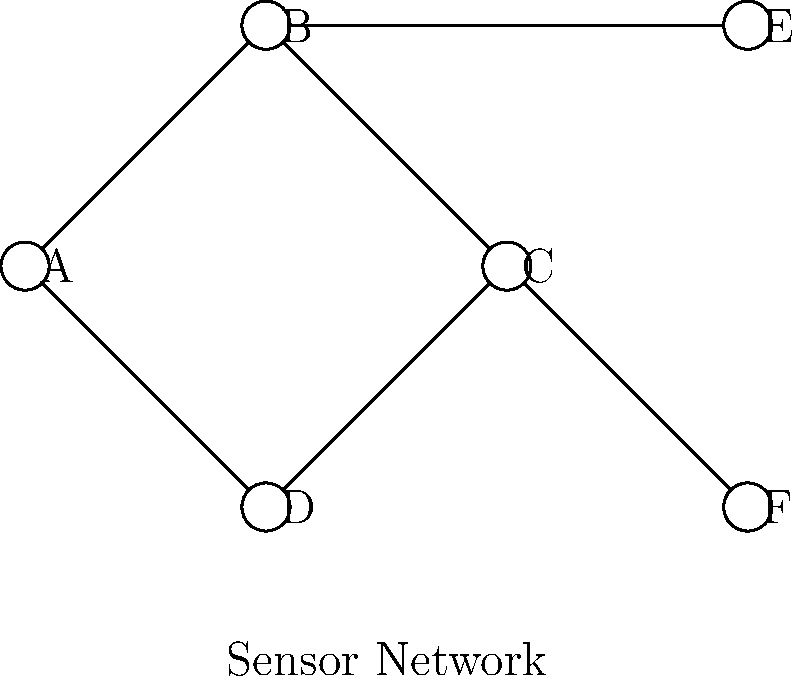In the context of environmental data collection, consider the sensor network topology shown above. Which node(s) would be most critical for maintaining network connectivity and ensuring comprehensive data collection across the entire area? Explain your reasoning based on the network structure and its implications for environmental monitoring. To determine the most critical node(s) for maintaining network connectivity and ensuring comprehensive data collection, we need to analyze the network topology:

1. Identify the central nodes:
   - Node B and Node C are connected to the most other nodes (3 connections each).
   - They form a bridge between the outer nodes.

2. Assess the impact of node removal:
   - Removing Node A, D, E, or F would only disconnect that single node.
   - Removing Node B would disconnect Node E from the rest of the network.
   - Removing Node C would disconnect Node F from the rest of the network.

3. Consider data flow:
   - Nodes B and C act as data aggregation points, collecting information from their connected nodes.
   - They are crucial for relaying data between different parts of the network.

4. Evaluate geographical coverage:
   - Nodes B and C are centrally located, likely covering a significant area of the monitored environment.
   - Their position allows them to collect data from different directions.

5. Redundancy and resilience:
   - The connection between B and C provides a level of redundancy.
   - If either B or C fails, the network can still maintain overall connectivity.

6. Energy efficiency:
   - As central nodes, B and C may handle more data traffic, potentially consuming more energy.
   - Their failure could lead to increased energy consumption in other nodes to maintain connectivity.

Based on this analysis, Nodes B and C are the most critical for maintaining network connectivity and ensuring comprehensive data collection. They serve as central hubs, connecting different parts of the network and likely covering key areas of the monitored environment.
Answer: Nodes B and C 